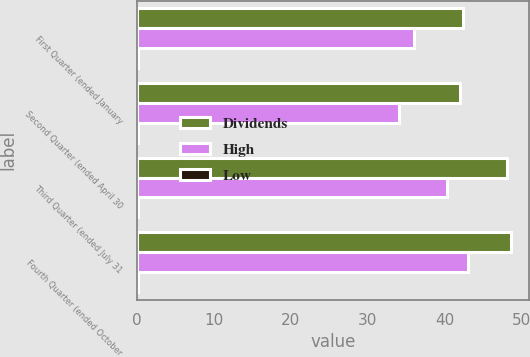Convert chart to OTSL. <chart><loc_0><loc_0><loc_500><loc_500><stacked_bar_chart><ecel><fcel>First Quarter (ended January<fcel>Second Quarter (ended April 30<fcel>Third Quarter (ended July 31<fcel>Fourth Quarter (ended October<nl><fcel>Dividends<fcel>42.48<fcel>42<fcel>48.18<fcel>48.63<nl><fcel>High<fcel>36.01<fcel>34.15<fcel>40.39<fcel>43.11<nl><fcel>Low<fcel>0.12<fcel>0.12<fcel>0.12<fcel>0.12<nl></chart> 